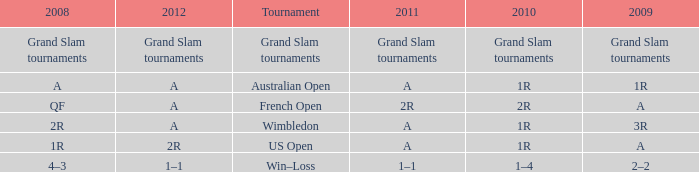Name the 2011 when 2010 is 2r 2R. 